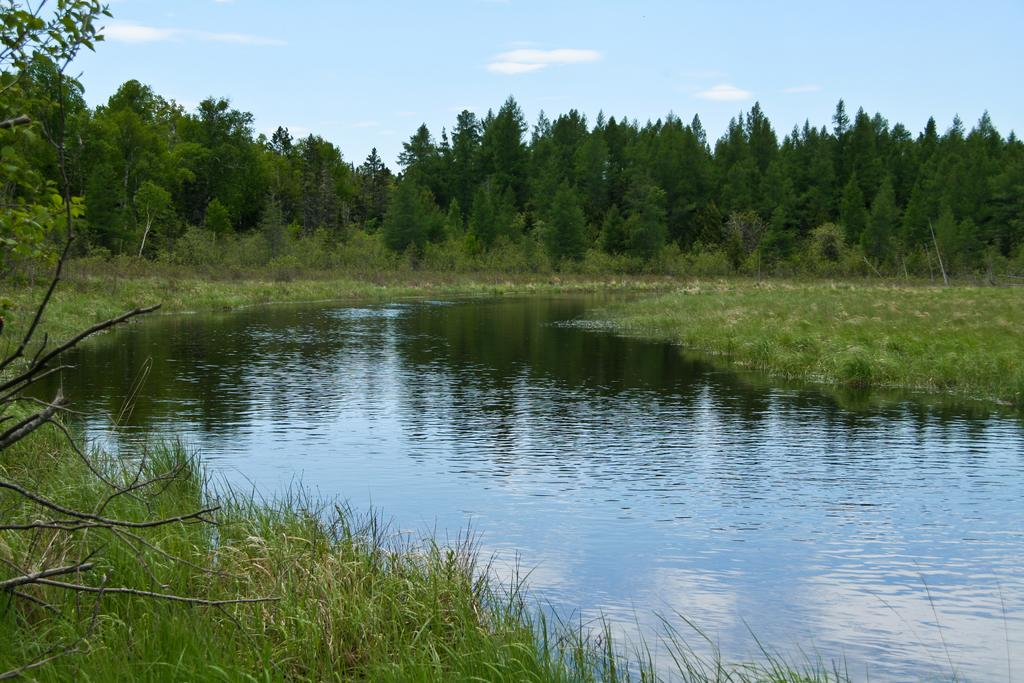What type of natural feature is present in the image? There is a lake in the image. How is the water in the lake behaving? The water in the lake is flowing. What type of vegetation can be seen in the image? There is grass, trees, and small plants visible in the image. What type of government is depicted in the image? There is no government depicted in the image; it features a lake with flowing water and various types of vegetation. Can you hear any music playing in the image? There is no music present in the image; it is a visual representation of a lake and its surroundings. 